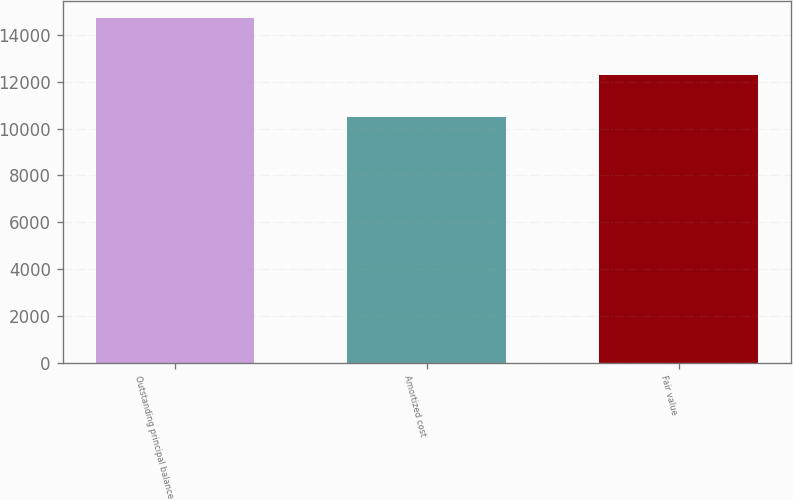<chart> <loc_0><loc_0><loc_500><loc_500><bar_chart><fcel>Outstanding principal balance<fcel>Amortized cost<fcel>Fair value<nl><fcel>14718<fcel>10492<fcel>12293<nl></chart> 